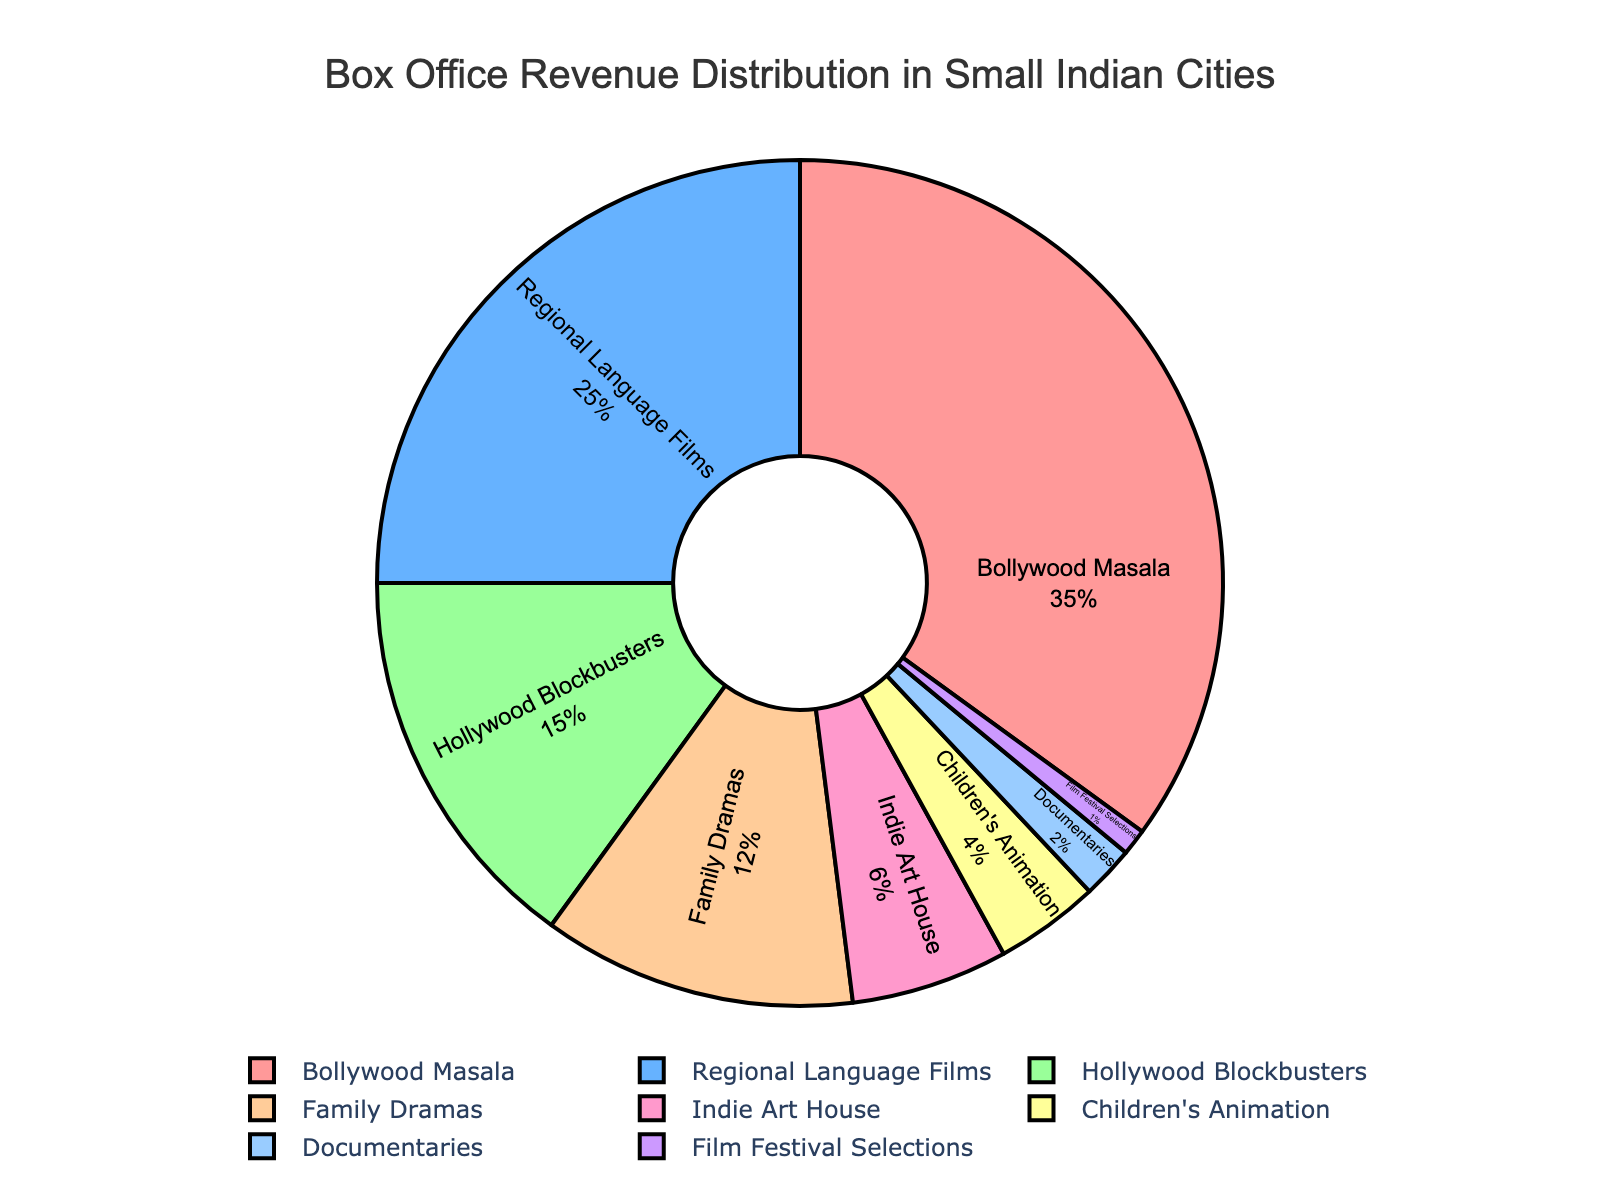Which movie type contributes the highest percentage to box office revenue? The largest slice in the pie chart represents the movie type with the highest box office revenue percentage. Bollywood Masala occupies the largest section.
Answer: Bollywood Masala What is the total box office revenue percentage for Family Dramas and Bollywood Masala combined? Add the percentages of Family Dramas (12%) and Bollywood Masala (35%). 12 + 35 = 47
Answer: 47 How much more revenue do Regional Language Films generate compared to Film Festival Selections? Subtract the percentage of Film Festival Selections (1%) from the percentage of Regional Language Films (25%). 25 - 1 = 24
Answer: 24 Which type of movie generates the lowest box office revenue? The smallest slice in the pie chart represents the movie type with the lowest box office revenue percentage. Film Festival Selections occupies the smallest section.
Answer: Film Festival Selections Compare the box office revenue percentage of Indie Art House to that of Documentaries. Which one generates more and by how much? Indie Art House contributes 6% and Documentaries contribute 2%. Subtract the percentage of Documentaries from Indie Art House. 6 - 2 = 4
Answer: Indie Art House, 4 What is the combined box office revenue percentage of Hollywood Blockbusters, Family Dramas, and Children's Animation? Add the percentages for Hollywood Blockbusters (15%), Family Dramas (12%), and Children's Animation (4%). 15 + 12 + 4 = 31
Answer: 31 Which genre has a box office revenue percentage closest to the average revenue percentage of all the genres? First, calculate the average revenue percentage: 
(35 + 25 + 15 + 12 + 6 + 4 + 2 + 1) / 8 = 12.5.
Then compare each genre's percentage to find the closest one. Family Dramas has a percentage of 12%, which is closest to 12.5%.
Answer: Family Dramas What are the percentages of the genres that generate more than 10% but less than 20% of the box office revenue? Identify the genres with percentages in that range: Hollywood Blockbusters (15%) and Family Dramas (12%).
Answer: Hollywood Blockbusters, Family Dramas Which genre's box office revenue percentage is represented by the light blue color? The light blue color corresponds to the percentage of Regional Language Films (25%) as displayed in the pie chart.
Answer: Regional Language Films How much lower is the box office revenue percentage of Children's Animation compared to Bollywood Masala? Subtract the percentage of Children's Animation (4%) from the percentage of Bollywood Masala (35%). 35 - 4 = 31
Answer: 31 